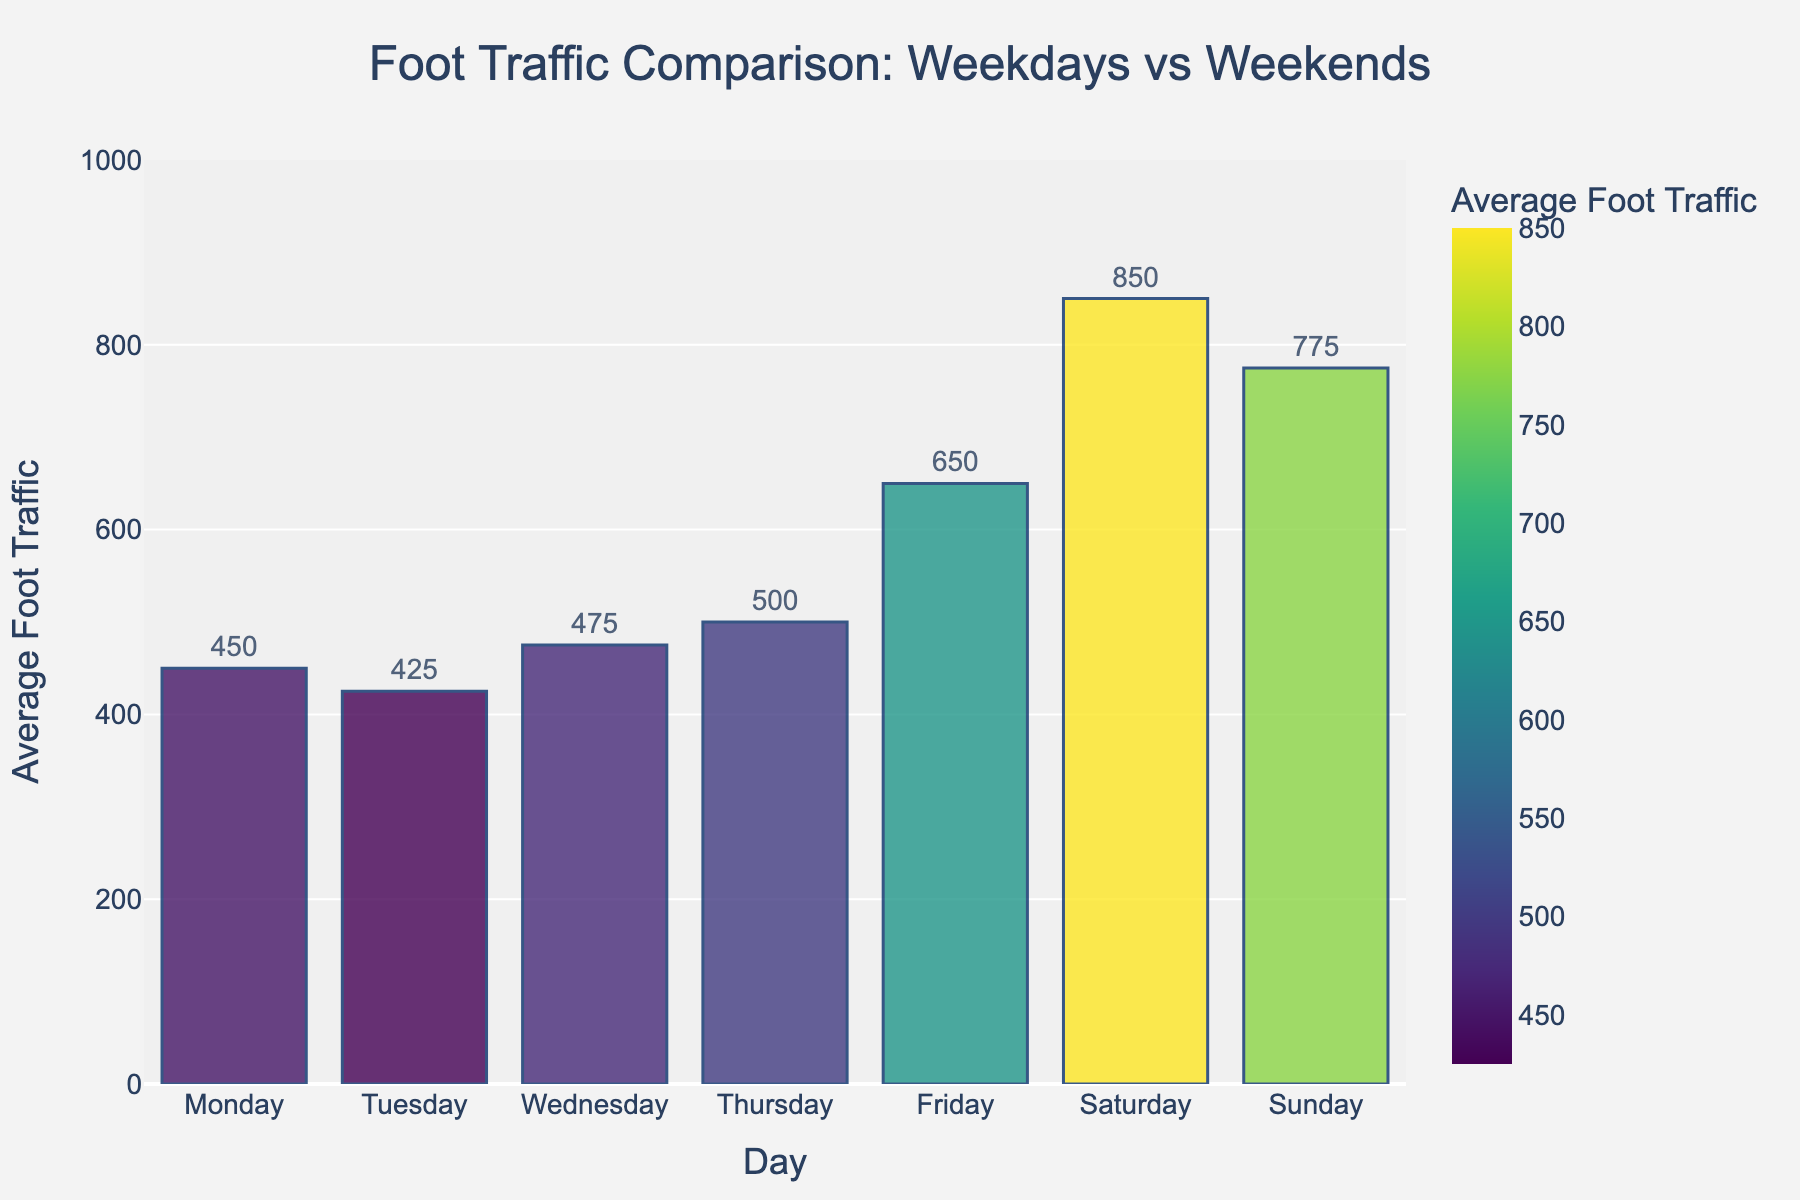What is the average foot traffic on weekdays? To find the average foot traffic on weekdays, add the values for Monday, Tuesday, Wednesday, Thursday, and Friday, and then divide by the number of days (5). (450 + 425 + 475 + 500 + 650) / 5 = 2500 / 5
Answer: 500 What is the difference in foot traffic between the highest and lowest days? The highest foot traffic is on Saturday (850) and the lowest is on Tuesday (425). Subtract the lowest from the highest. 850 - 425
Answer: 425 Which day has the highest foot traffic? From the bar chart, observe the tallest bar. The tallest bar is Saturday, indicating the highest foot traffic.
Answer: Saturday How does foot traffic on Sunday compare to Thursday? Compare the heights of the bars for Sunday and Thursday. Sunday has 775, and Thursday has 500; hence, Sunday has higher foot traffic.
Answer: Sunday is higher What is the total foot traffic for the entire week? Add the foot traffic numbers for all seven days: 450 + 425 + 475 + 500 + 650 + 850 + 775.
Answer: 4125 Which has more foot traffic on average: weekdays or weekends? Calculate the average foot traffic for weekdays and weekends. Weekdays: (450 + 425 + 475 + 500 + 650) / 5 = 500. Weekends: (850 + 775) / 2 = 812.5. Compare the two averages.
Answer: Weekends Is there a significant drop in foot traffic from Saturday to Sunday? Compare the numbers for Saturday (850) and Sunday (775). Calculate the difference: 850 - 775 = 75. Assess if this difference is significant.
Answer: Yes, there is a drop of 75 What is the cumulative foot traffic for Friday, Saturday, and Sunday combined? Add the foot traffic numbers for these three days: 650 + 850 + 775.
Answer: 2275 Which weekday has the lowest foot traffic? Inspect the bars for Monday to Friday. The shortest bar among these is Tuesday with 425.
Answer: Tuesday 